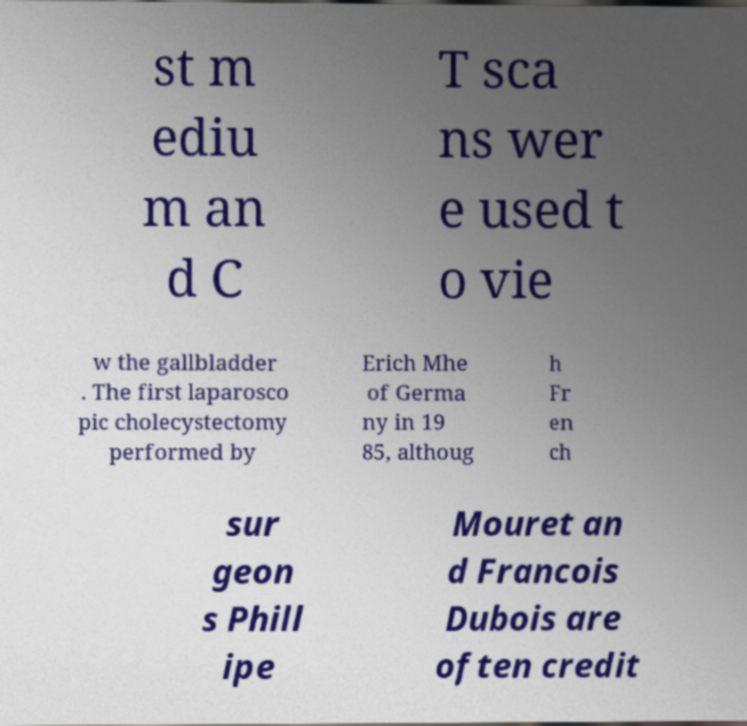Please identify and transcribe the text found in this image. st m ediu m an d C T sca ns wer e used t o vie w the gallbladder . The first laparosco pic cholecystectomy performed by Erich Mhe of Germa ny in 19 85, althoug h Fr en ch sur geon s Phill ipe Mouret an d Francois Dubois are often credit 